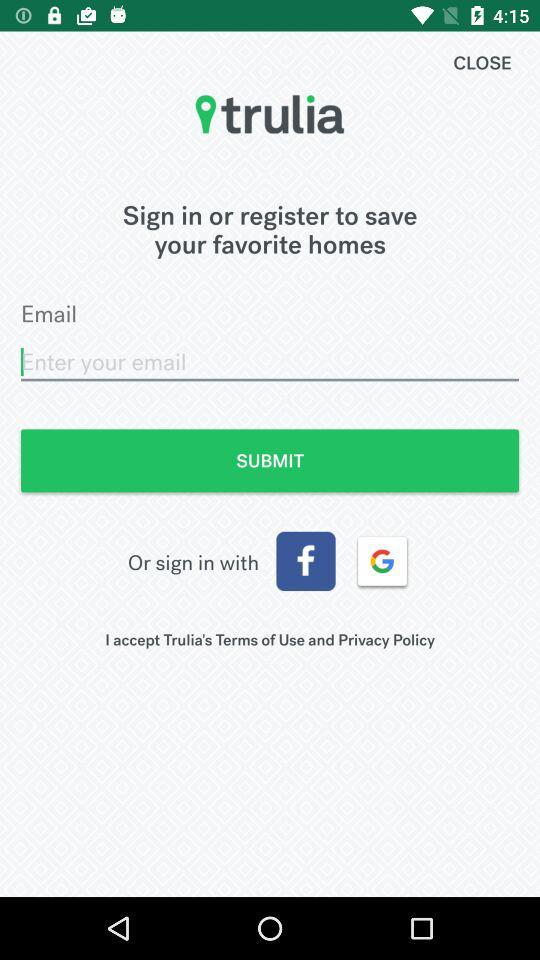How many more sign in options are there than social media sign in options?
Answer the question using a single word or phrase. 1 